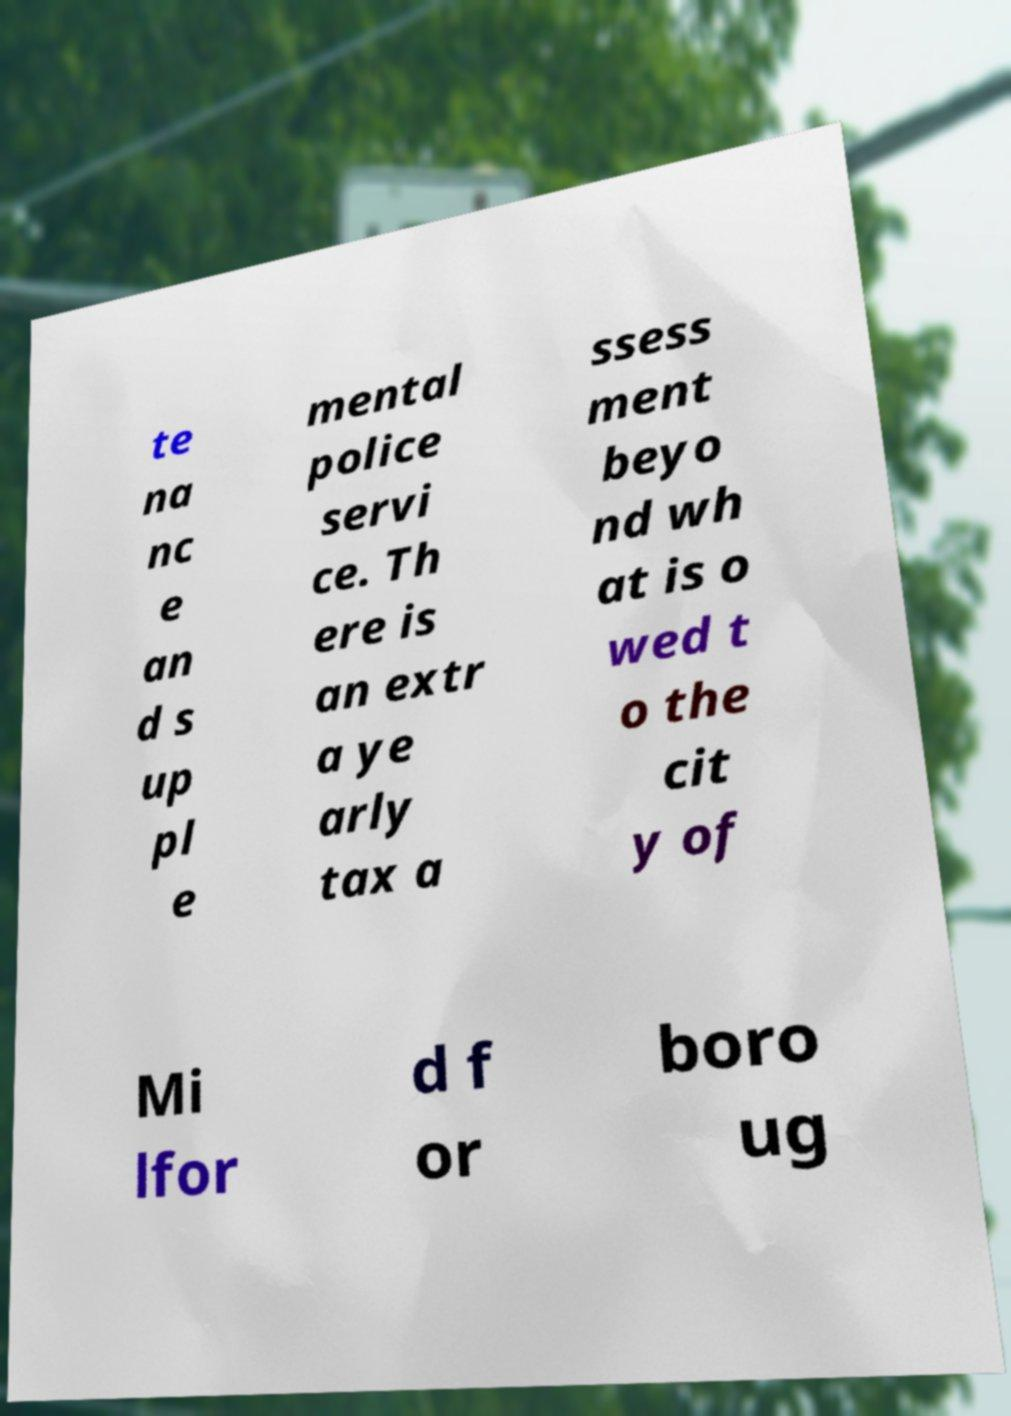Please read and relay the text visible in this image. What does it say? te na nc e an d s up pl e mental police servi ce. Th ere is an extr a ye arly tax a ssess ment beyo nd wh at is o wed t o the cit y of Mi lfor d f or boro ug 